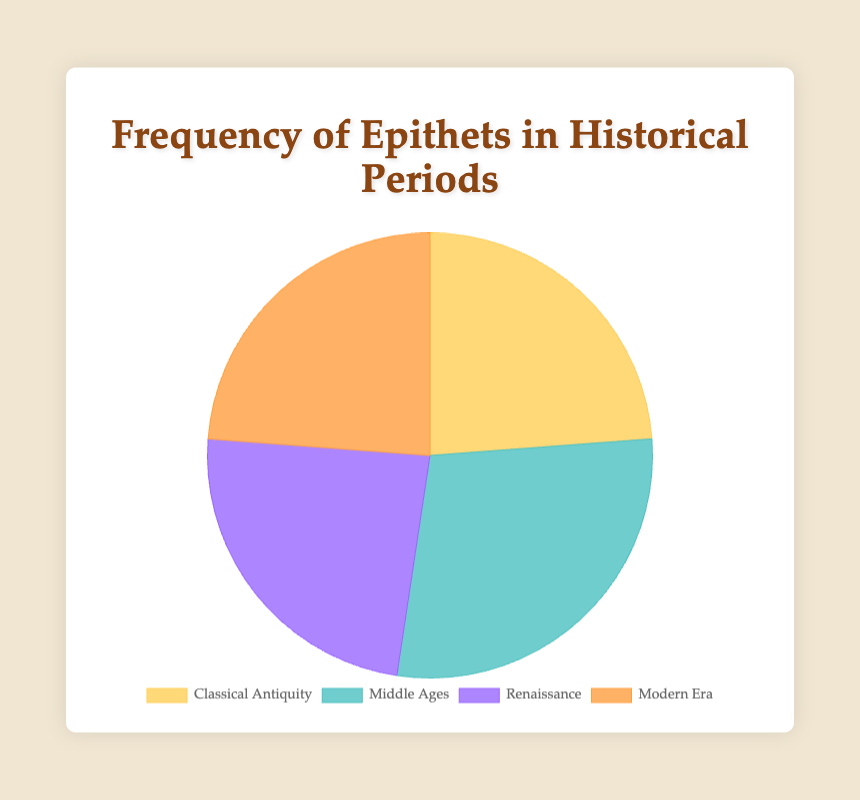What historical period has the highest total number of epithets? By summing the epithets for each period, we get Classical Antiquity: 35 + 45 + 20 = 100, Middle Ages: 40 + 50 + 30 = 120, Renaissance: 35 + 40 + 25 = 100, Modern Era: 30 + 35 + 35 = 100. The Middle Ages have the highest total number of epithets with 120.
Answer: Middle Ages Which historical period has the lowest total number of epithets? By summing the epithets for each period, we see that Classical Antiquity: 35 + 45 + 20 = 100, Middle Ages: 40 + 50 + 30 = 120, Renaissance: 35 + 40 + 25 = 100, Modern Era: 30 + 35 + 35 = 100. Both Classical Antiquity, Renaissance, and Modern Era have the lowest total with 100 each.
Answer: Classical Antiquity, Renaissance, and Modern Era What is the total number of epithets for both Classical Antiquity and Renaissance combined? For Classical Antiquity, the total is 35 + 45 + 20 = 100. For Renaissance, it is 35 + 40 + 25 = 100. The combined total is 100 + 100 = 200.
Answer: 200 Which period has more epithets: Modern Era or Classical Antiquity? By summing the epithets, Classical Antiquity has 35 + 45 + 20 = 100 and Modern Era has 30 + 35 + 35 = 100. They have an equal number of epithets.
Answer: They are equal What percentage of epithets does the Middle Ages contribute to the total number across all periods? First, the total number of epithets from all periods: 100 (Classical Antiquity) + 120 (Middle Ages) + 100 (Renaissance) + 100 (Modern Era) = 420. The Middle Ages contribute 120 epithets. The percentage is (120/420) * 100 ≈ 28.57%.
Answer: 28.57% What is the difference in the number of epithets between the Middle Ages and the Classical Antiquity? Classical Antiquity has 35 + 45 + 20 = 100, and Middle Ages have 40 + 50 + 30 = 120. The difference is 120 - 100 = 20.
Answer: 20 Which category has the highest number of epithets in the Middle Ages? The categories in the Middle Ages are: Royal Titles (40), Chivalric Epithets (50), and Religious Epithets (30). Chivalric Epithets have the highest number with 50.
Answer: Chivalric Epithets What is the average number of epithets for the Renaissance period? The categories in the Renaissance period are Humanist Names (35), Aristocratic Titles (40), and Artist Nicknames (25). The average is (35 + 40 + 25) / 3 = 33.33.
Answer: 33.33 What is the sum of Chivalric Epithets and Olympian Epithets? The number of Chivalric Epithets in the Middle Ages is 50, and the number of Olympian Epithets in Classical Antiquity is 20. The sum is 50 + 20 = 70.
Answer: 70 